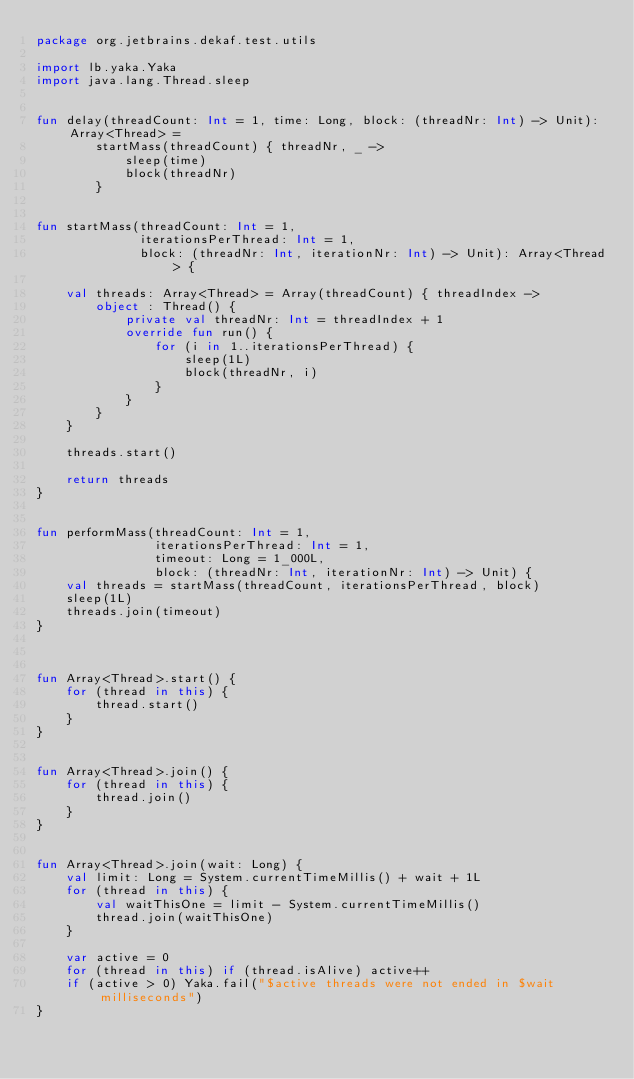Convert code to text. <code><loc_0><loc_0><loc_500><loc_500><_Kotlin_>package org.jetbrains.dekaf.test.utils

import lb.yaka.Yaka
import java.lang.Thread.sleep


fun delay(threadCount: Int = 1, time: Long, block: (threadNr: Int) -> Unit): Array<Thread> =
        startMass(threadCount) { threadNr, _ ->
            sleep(time)
            block(threadNr)
        }


fun startMass(threadCount: Int = 1,
              iterationsPerThread: Int = 1,
              block: (threadNr: Int, iterationNr: Int) -> Unit): Array<Thread> {

    val threads: Array<Thread> = Array(threadCount) { threadIndex ->
        object : Thread() {
            private val threadNr: Int = threadIndex + 1
            override fun run() {
                for (i in 1..iterationsPerThread) {
                    sleep(1L)
                    block(threadNr, i)
                }
            }
        }
    }

    threads.start()

    return threads
}


fun performMass(threadCount: Int = 1,
                iterationsPerThread: Int = 1,
                timeout: Long = 1_000L,
                block: (threadNr: Int, iterationNr: Int) -> Unit) {
    val threads = startMass(threadCount, iterationsPerThread, block)
    sleep(1L)
    threads.join(timeout)
}



fun Array<Thread>.start() {
    for (thread in this) {
        thread.start()
    }
}


fun Array<Thread>.join() {
    for (thread in this) {
        thread.join()
    }
}


fun Array<Thread>.join(wait: Long) {
    val limit: Long = System.currentTimeMillis() + wait + 1L
    for (thread in this) {
        val waitThisOne = limit - System.currentTimeMillis()
        thread.join(waitThisOne)
    }

    var active = 0
    for (thread in this) if (thread.isAlive) active++
    if (active > 0) Yaka.fail("$active threads were not ended in $wait milliseconds")
}




</code> 